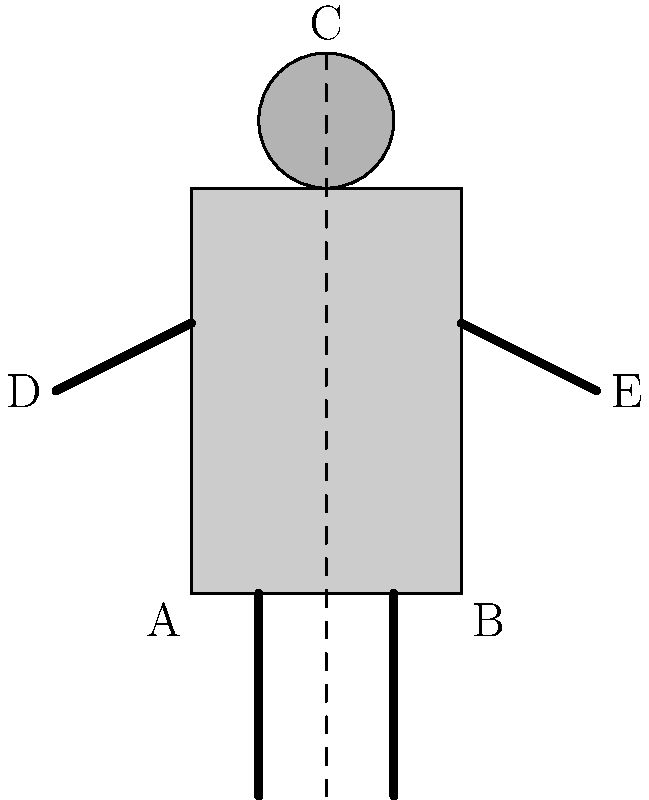In the robotic character design shown, point C represents the top of the head, while points A and B mark the bottom corners of the body. If the ratio of the robot's height (distance AC) to its width (distance AB) is 2:1, and the arm span (distance DE) is 1.5 times the body width, what is the ratio of the robot's arm span to its height? Let's approach this step-by-step:

1) We're told that the ratio of height to width is 2:1. Let's express this mathematically:
   $$\frac{AC}{AB} = 2:1 = 2$$

2) We're also told that the arm span (DE) is 1.5 times the body width (AB):
   $$DE = 1.5 \times AB$$

3) Now, we want to find the ratio of arm span to height. In other words, we're looking for $\frac{DE}{AC}$.

4) We can express DE in terms of AB:
   $$\frac{DE}{AC} = \frac{1.5AB}{AC}$$

5) We know that $AC = 2AB$ from step 1, so let's substitute this:
   $$\frac{DE}{AC} = \frac{1.5AB}{2AB}$$

6) The AB terms cancel out:
   $$\frac{DE}{AC} = \frac{1.5}{2}$$

7) Simplify the fraction:
   $$\frac{DE}{AC} = \frac{3}{4}$$

Therefore, the ratio of the robot's arm span to its height is 3:4.
Answer: 3:4 